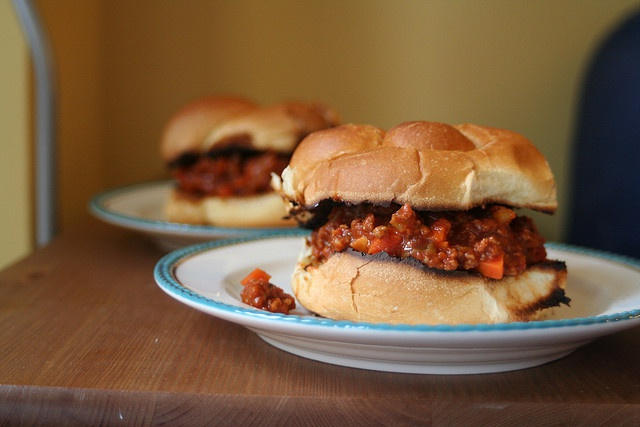Describe the objects in this image and their specific colors. I can see dining table in olive, maroon, black, and brown tones, sandwich in olive, tan, brown, maroon, and black tones, and sandwich in olive, brown, maroon, and tan tones in this image. 